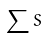<formula> <loc_0><loc_0><loc_500><loc_500>\sum { S }</formula> 